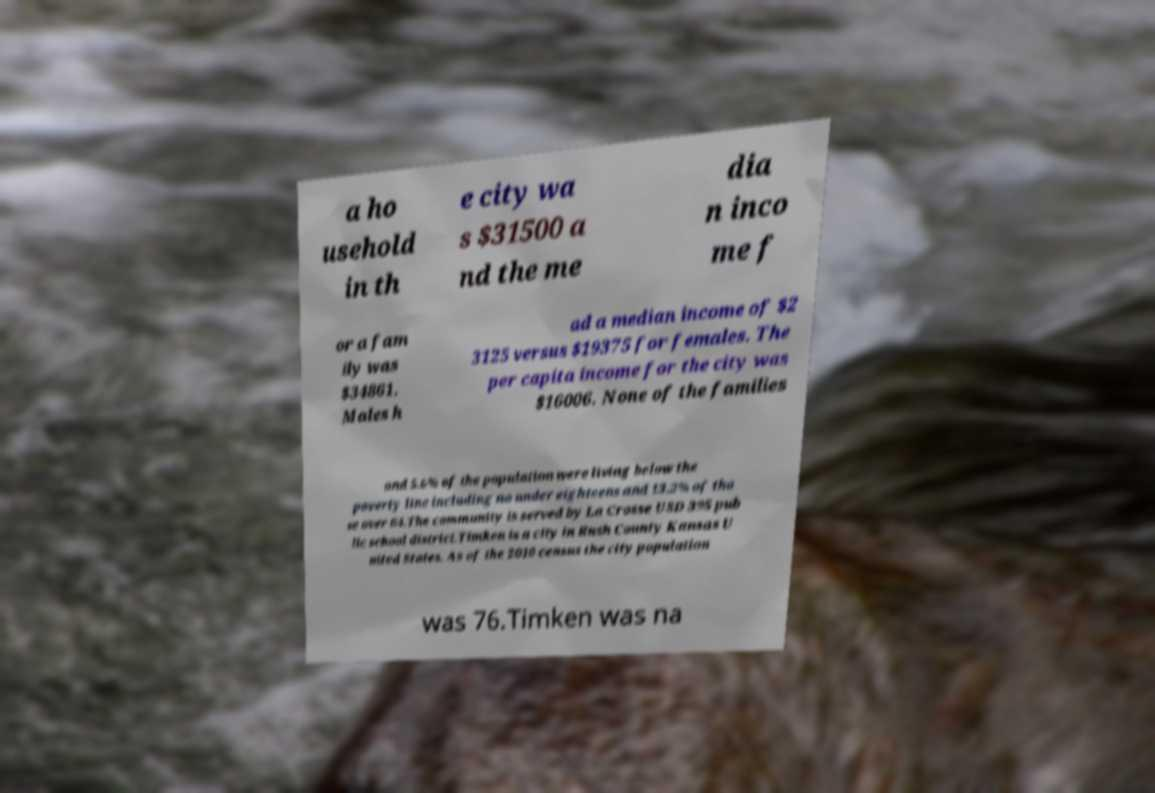Please identify and transcribe the text found in this image. a ho usehold in th e city wa s $31500 a nd the me dia n inco me f or a fam ily was $34861. Males h ad a median income of $2 3125 versus $19375 for females. The per capita income for the city was $16006. None of the families and 5.6% of the population were living below the poverty line including no under eighteens and 13.2% of tho se over 64.The community is served by La Crosse USD 395 pub lic school district.Timken is a city in Rush County Kansas U nited States. As of the 2010 census the city population was 76.Timken was na 